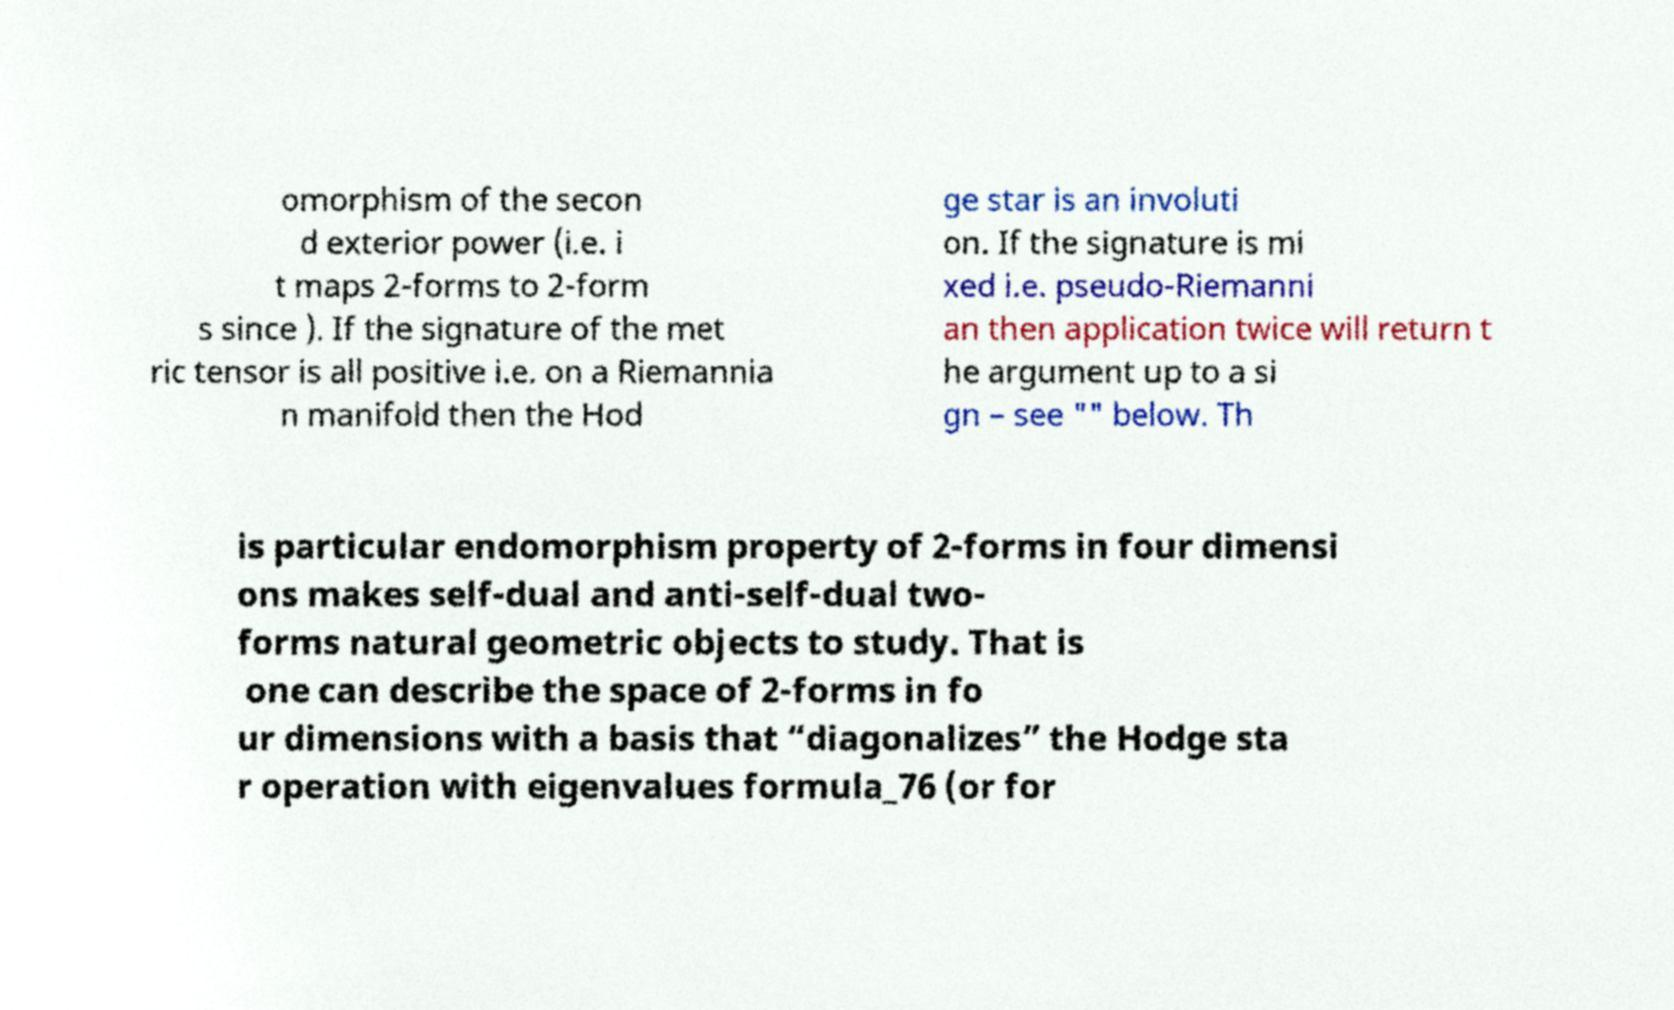There's text embedded in this image that I need extracted. Can you transcribe it verbatim? omorphism of the secon d exterior power (i.e. i t maps 2-forms to 2-form s since ). If the signature of the met ric tensor is all positive i.e. on a Riemannia n manifold then the Hod ge star is an involuti on. If the signature is mi xed i.e. pseudo-Riemanni an then application twice will return t he argument up to a si gn – see "" below. Th is particular endomorphism property of 2-forms in four dimensi ons makes self-dual and anti-self-dual two- forms natural geometric objects to study. That is one can describe the space of 2-forms in fo ur dimensions with a basis that “diagonalizes” the Hodge sta r operation with eigenvalues formula_76 (or for 